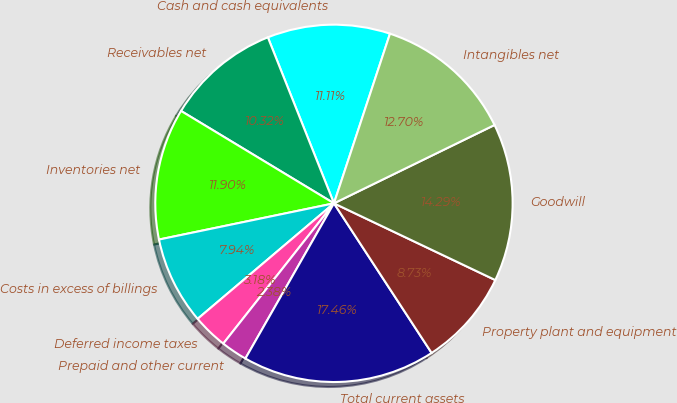Convert chart to OTSL. <chart><loc_0><loc_0><loc_500><loc_500><pie_chart><fcel>Cash and cash equivalents<fcel>Receivables net<fcel>Inventories net<fcel>Costs in excess of billings<fcel>Deferred income taxes<fcel>Prepaid and other current<fcel>Total current assets<fcel>Property plant and equipment<fcel>Goodwill<fcel>Intangibles net<nl><fcel>11.11%<fcel>10.32%<fcel>11.9%<fcel>7.94%<fcel>3.18%<fcel>2.38%<fcel>17.46%<fcel>8.73%<fcel>14.29%<fcel>12.7%<nl></chart> 